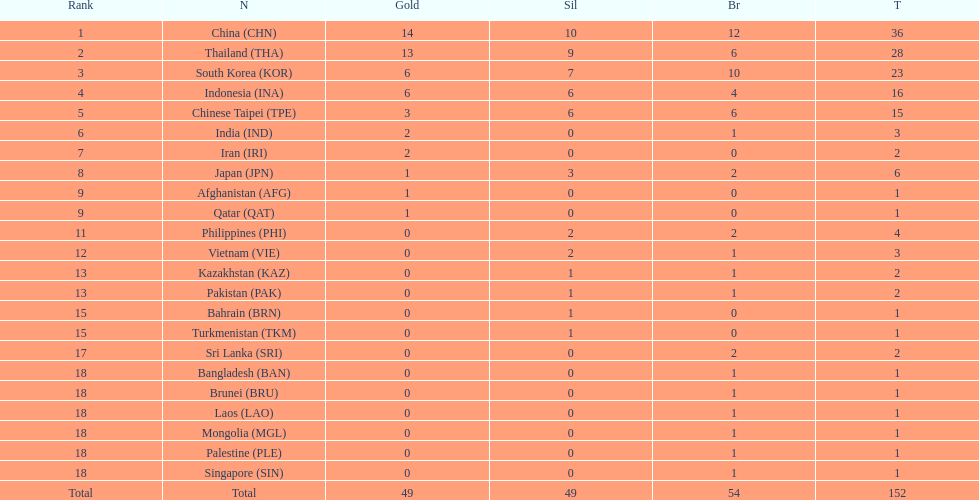Parse the full table. {'header': ['Rank', 'N', 'Gold', 'Sil', 'Br', 'T'], 'rows': [['1', 'China\xa0(CHN)', '14', '10', '12', '36'], ['2', 'Thailand\xa0(THA)', '13', '9', '6', '28'], ['3', 'South Korea\xa0(KOR)', '6', '7', '10', '23'], ['4', 'Indonesia\xa0(INA)', '6', '6', '4', '16'], ['5', 'Chinese Taipei\xa0(TPE)', '3', '6', '6', '15'], ['6', 'India\xa0(IND)', '2', '0', '1', '3'], ['7', 'Iran\xa0(IRI)', '2', '0', '0', '2'], ['8', 'Japan\xa0(JPN)', '1', '3', '2', '6'], ['9', 'Afghanistan\xa0(AFG)', '1', '0', '0', '1'], ['9', 'Qatar\xa0(QAT)', '1', '0', '0', '1'], ['11', 'Philippines\xa0(PHI)', '0', '2', '2', '4'], ['12', 'Vietnam\xa0(VIE)', '0', '2', '1', '3'], ['13', 'Kazakhstan\xa0(KAZ)', '0', '1', '1', '2'], ['13', 'Pakistan\xa0(PAK)', '0', '1', '1', '2'], ['15', 'Bahrain\xa0(BRN)', '0', '1', '0', '1'], ['15', 'Turkmenistan\xa0(TKM)', '0', '1', '0', '1'], ['17', 'Sri Lanka\xa0(SRI)', '0', '0', '2', '2'], ['18', 'Bangladesh\xa0(BAN)', '0', '0', '1', '1'], ['18', 'Brunei\xa0(BRU)', '0', '0', '1', '1'], ['18', 'Laos\xa0(LAO)', '0', '0', '1', '1'], ['18', 'Mongolia\xa0(MGL)', '0', '0', '1', '1'], ['18', 'Palestine\xa0(PLE)', '0', '0', '1', '1'], ['18', 'Singapore\xa0(SIN)', '0', '0', '1', '1'], ['Total', 'Total', '49', '49', '54', '152']]} Who secured a higher total of medals, the philippines or kazakhstan? Philippines. 